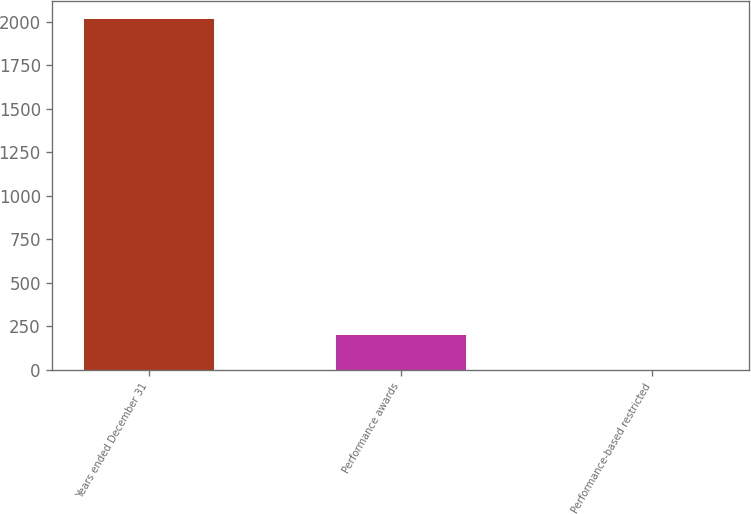<chart> <loc_0><loc_0><loc_500><loc_500><bar_chart><fcel>Years ended December 31<fcel>Performance awards<fcel>Performance-based restricted<nl><fcel>2018<fcel>202.07<fcel>0.3<nl></chart> 